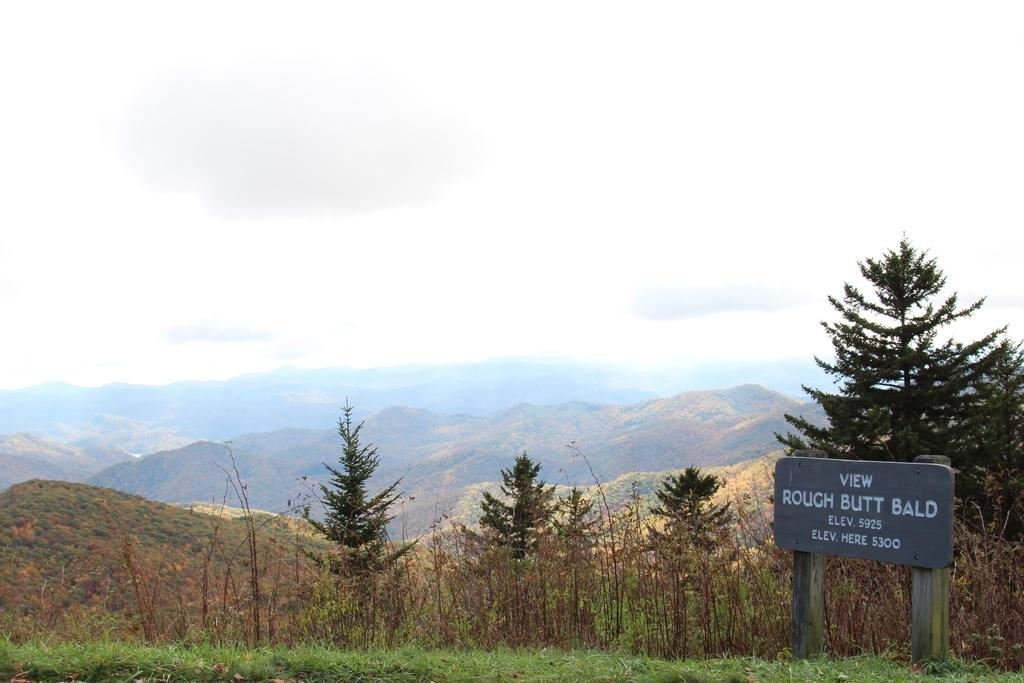What type of vegetation is present in the image? There is grass in the image. What object with text can be seen in the image? There is a wooden board with text in the image. What type of natural structure is visible in the image? There is a tree visible in the image. What distant geographical feature can be seen in the image? There are mountains in the image. What is visible at the top of the image? The sky is visible at the top of the image. Can you describe the harmony between the screw and the grass in the image? There is no screw present in the image, so it is not possible to describe any harmony between a screw and the grass. 